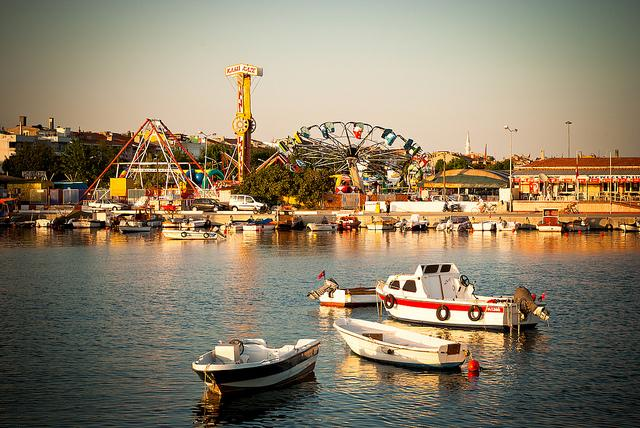Where can you see a similar scene to what is happening behind the boats?

Choices:
A) parking garage
B) king kullen
C) six flags
D) costco six flags 